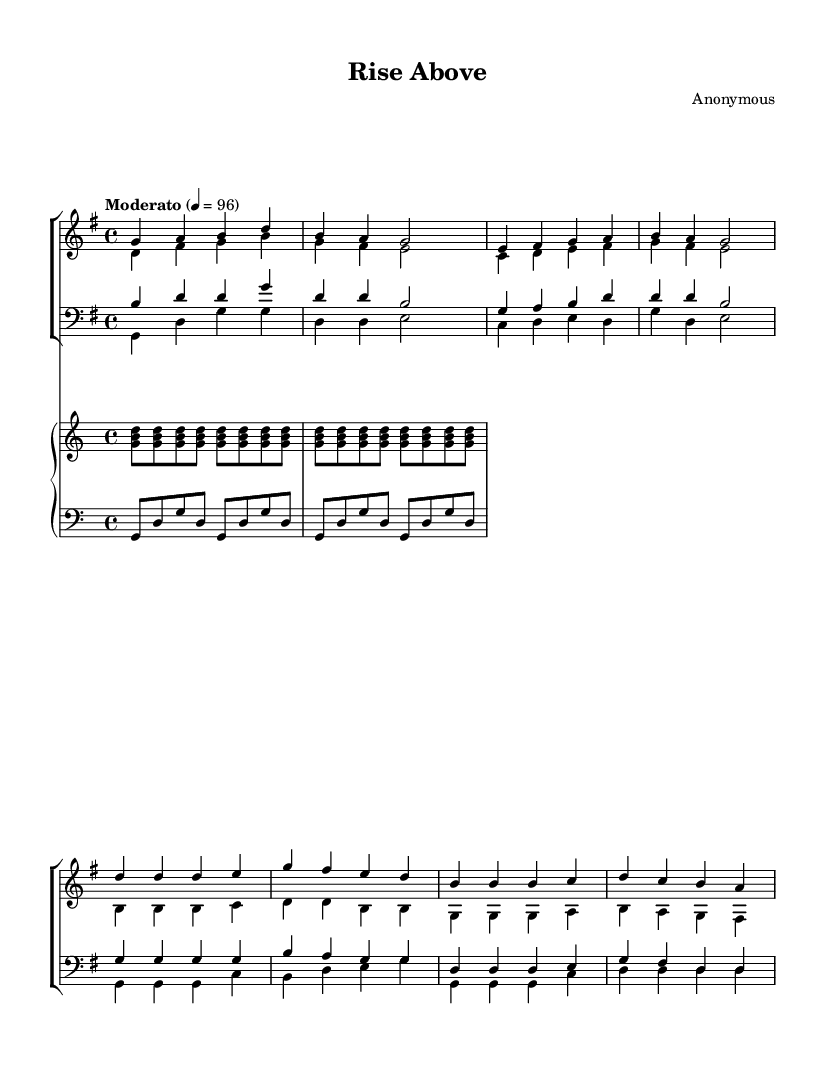What is the key signature of this music? The key signature is G major, which has one sharp (F#). This can be identified by looking at the key signature symbol at the beginning of the staff.
Answer: G major What is the time signature of this piece? The time signature is 4/4, which is indicated at the beginning of the score. This means there are four beats in each measure and the quarter note gets one beat.
Answer: 4/4 What is the tempo marking for this piece? The tempo marking is "Moderato," which suggests a moderate speed. This marking is indicated above the staff, stating the desired pace for the performance.
Answer: Moderato How many vocal parts are present in this score? There are four vocal parts: soprano, alto, tenor, and bass. This can be deduced by counting the separate vocal lines written for both women’s and men’s sections.
Answer: Four What note does the soprano start on in the verse? The soprano part starts on the note G. This can be identified by looking at the first note of the soprano verse, which is notated as G4.
Answer: G Which voice sings the highest pitch in the chorus? The soprano sings the highest pitch in the chorus. This can be determined by comparing the highest notes written across all the vocal lines in the chorus section.
Answer: Soprano What is the dynamic marking for this piece? The dynamic marking is not explicitly stated in the provided code, but generally, uplifting choral works often suggest a strong or robust performance, which would typically be indicated as "forte". There is no specific dynamic noted in this case, so one might infer a strong dynamic for an uplifting effect.
Answer: Forte 